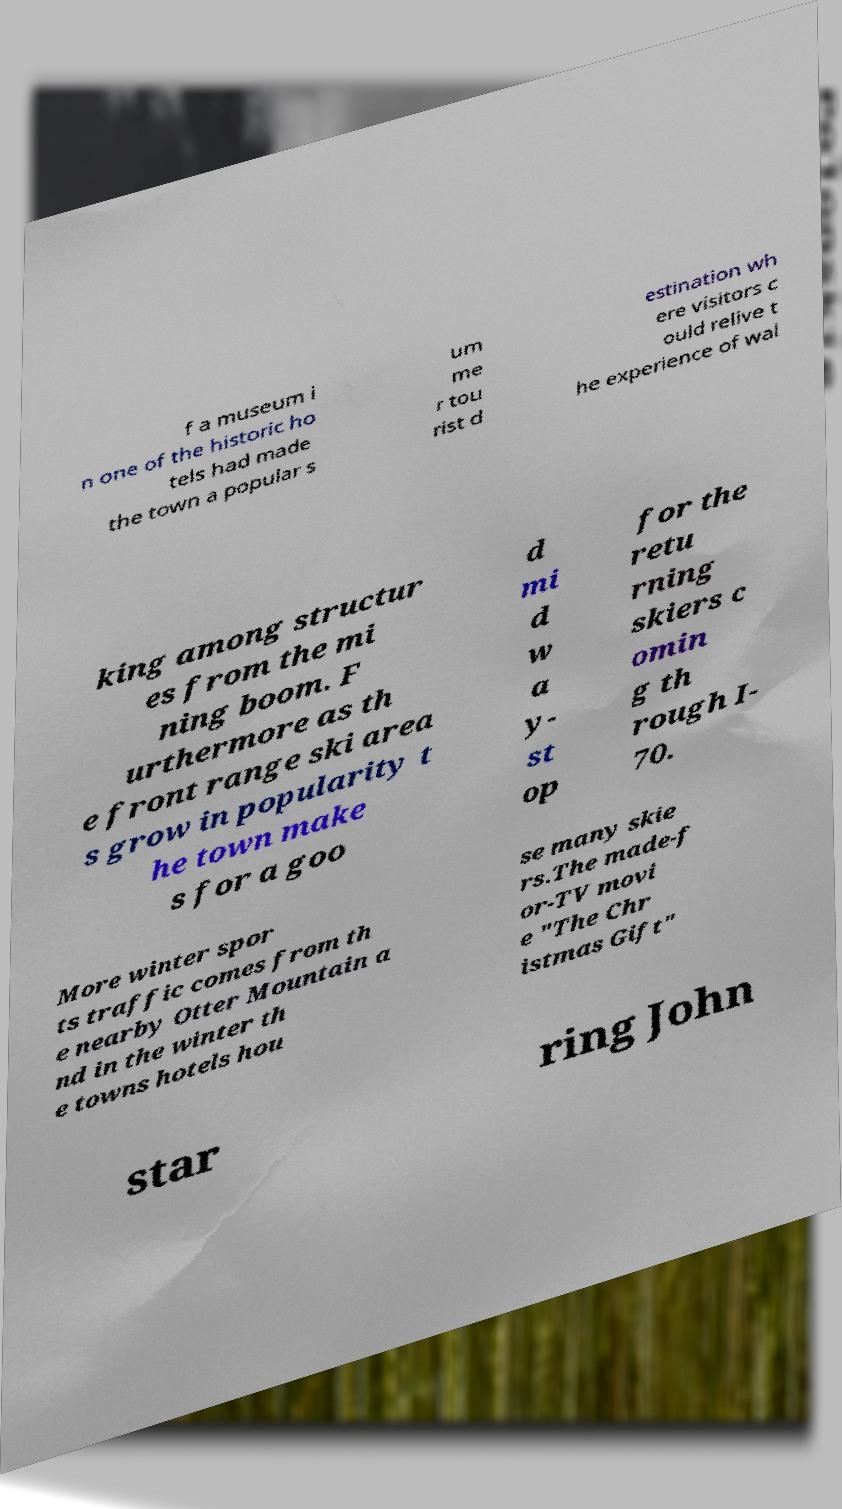Can you read and provide the text displayed in the image?This photo seems to have some interesting text. Can you extract and type it out for me? f a museum i n one of the historic ho tels had made the town a popular s um me r tou rist d estination wh ere visitors c ould relive t he experience of wal king among structur es from the mi ning boom. F urthermore as th e front range ski area s grow in popularity t he town make s for a goo d mi d w a y- st op for the retu rning skiers c omin g th rough I- 70. More winter spor ts traffic comes from th e nearby Otter Mountain a nd in the winter th e towns hotels hou se many skie rs.The made-f or-TV movi e "The Chr istmas Gift" star ring John 